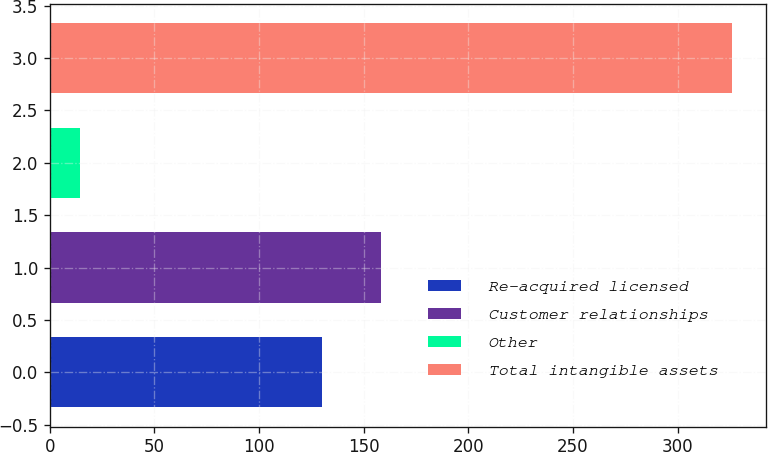Convert chart to OTSL. <chart><loc_0><loc_0><loc_500><loc_500><bar_chart><fcel>Re-acquired licensed<fcel>Customer relationships<fcel>Other<fcel>Total intangible assets<nl><fcel>130.2<fcel>158.51<fcel>14.5<fcel>325.91<nl></chart> 